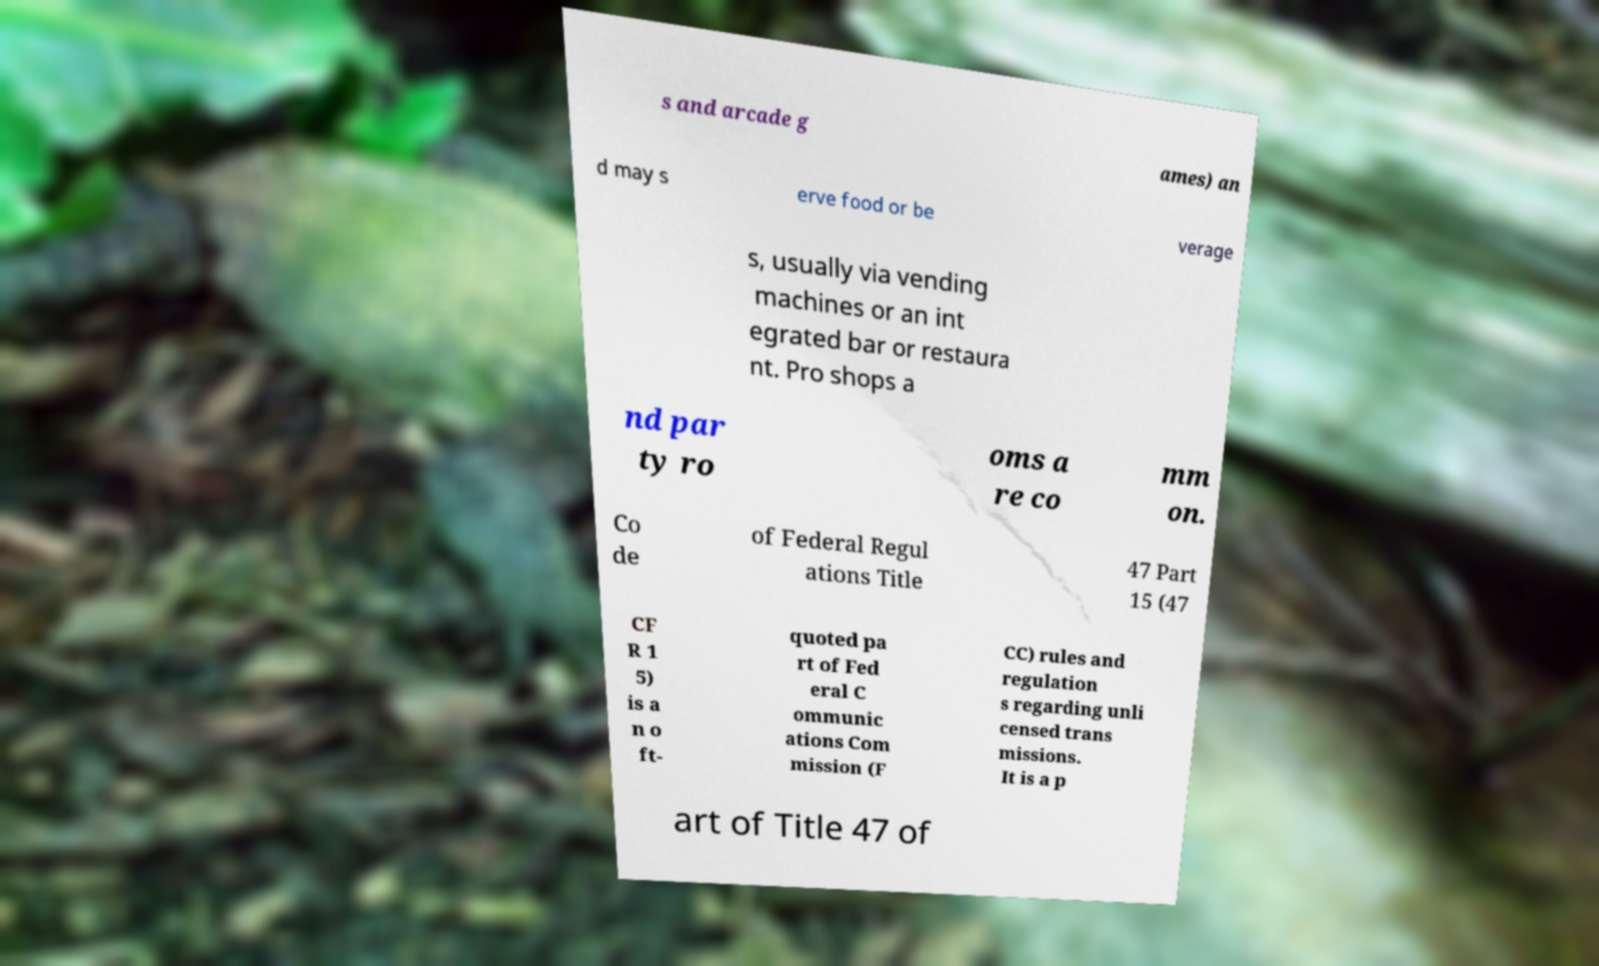Please identify and transcribe the text found in this image. s and arcade g ames) an d may s erve food or be verage s, usually via vending machines or an int egrated bar or restaura nt. Pro shops a nd par ty ro oms a re co mm on. Co de of Federal Regul ations Title 47 Part 15 (47 CF R 1 5) is a n o ft- quoted pa rt of Fed eral C ommunic ations Com mission (F CC) rules and regulation s regarding unli censed trans missions. It is a p art of Title 47 of 